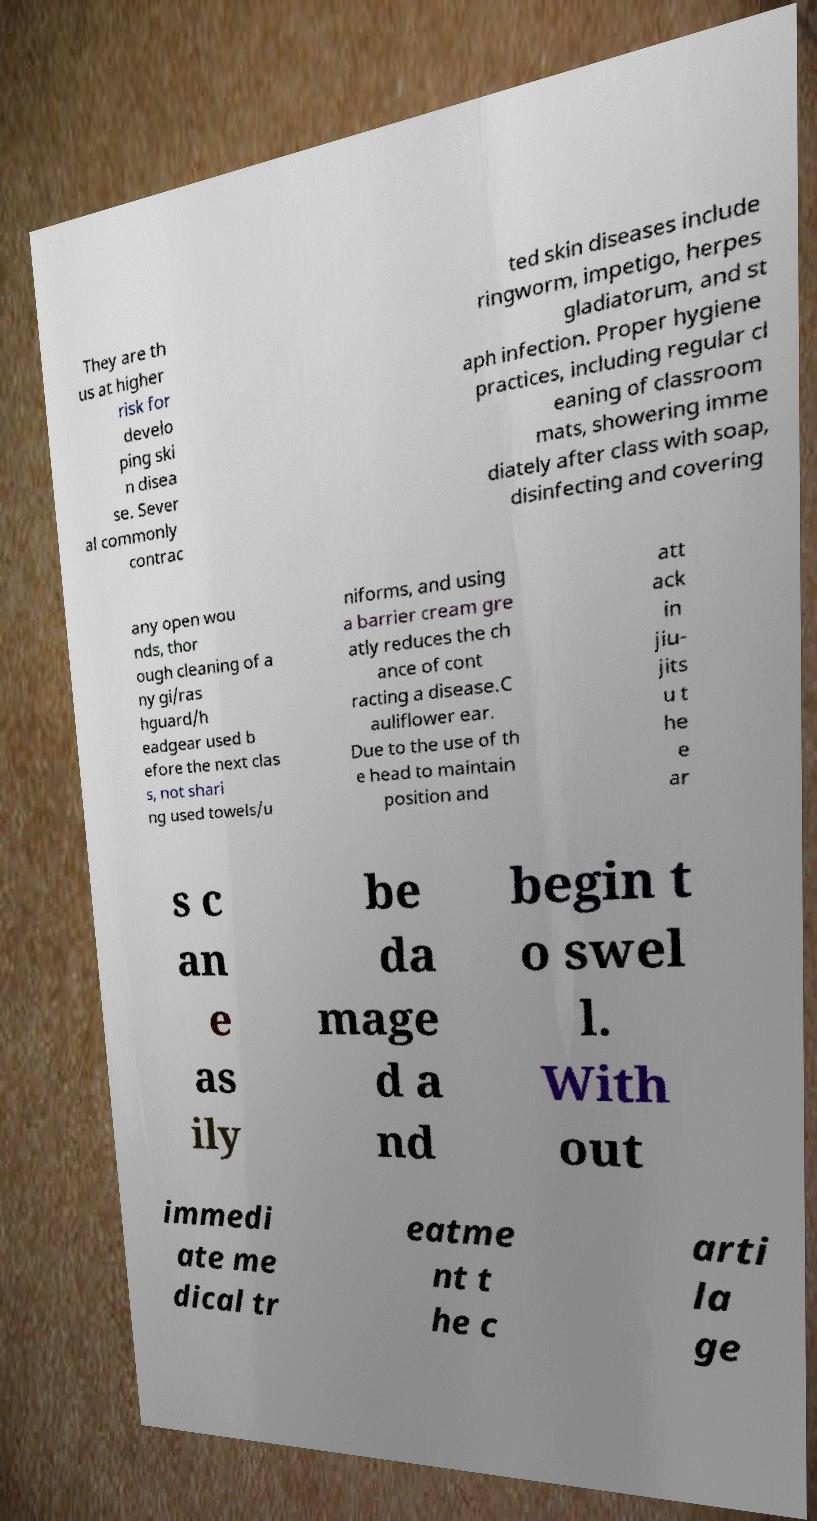Can you read and provide the text displayed in the image?This photo seems to have some interesting text. Can you extract and type it out for me? They are th us at higher risk for develo ping ski n disea se. Sever al commonly contrac ted skin diseases include ringworm, impetigo, herpes gladiatorum, and st aph infection. Proper hygiene practices, including regular cl eaning of classroom mats, showering imme diately after class with soap, disinfecting and covering any open wou nds, thor ough cleaning of a ny gi/ras hguard/h eadgear used b efore the next clas s, not shari ng used towels/u niforms, and using a barrier cream gre atly reduces the ch ance of cont racting a disease.C auliflower ear. Due to the use of th e head to maintain position and att ack in jiu- jits u t he e ar s c an e as ily be da mage d a nd begin t o swel l. With out immedi ate me dical tr eatme nt t he c arti la ge 